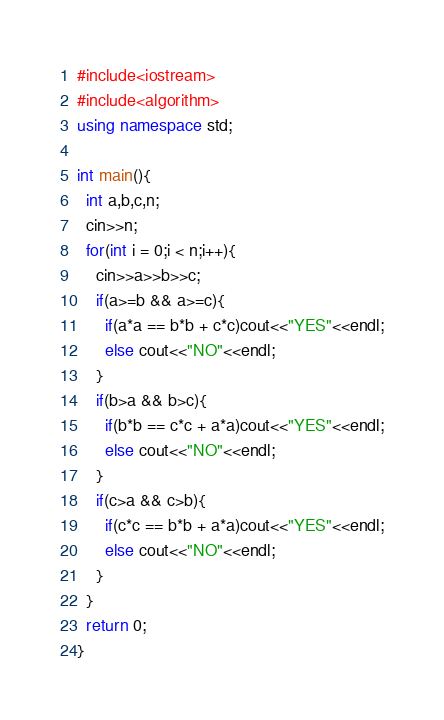Convert code to text. <code><loc_0><loc_0><loc_500><loc_500><_C++_>#include<iostream>
#include<algorithm>
using namespace std;

int main(){
  int a,b,c,n;
  cin>>n;
  for(int i = 0;i < n;i++){
    cin>>a>>b>>c;
    if(a>=b && a>=c){
      if(a*a == b*b + c*c)cout<<"YES"<<endl;
      else cout<<"NO"<<endl;
    }
    if(b>a && b>c){
      if(b*b == c*c + a*a)cout<<"YES"<<endl;
      else cout<<"NO"<<endl;
    }
    if(c>a && c>b){
      if(c*c == b*b + a*a)cout<<"YES"<<endl;
      else cout<<"NO"<<endl;
    }
  }
  return 0;
}</code> 